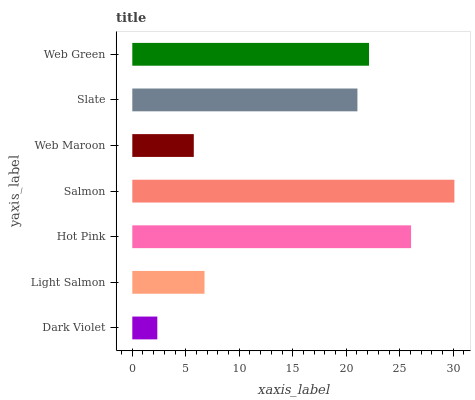Is Dark Violet the minimum?
Answer yes or no. Yes. Is Salmon the maximum?
Answer yes or no. Yes. Is Light Salmon the minimum?
Answer yes or no. No. Is Light Salmon the maximum?
Answer yes or no. No. Is Light Salmon greater than Dark Violet?
Answer yes or no. Yes. Is Dark Violet less than Light Salmon?
Answer yes or no. Yes. Is Dark Violet greater than Light Salmon?
Answer yes or no. No. Is Light Salmon less than Dark Violet?
Answer yes or no. No. Is Slate the high median?
Answer yes or no. Yes. Is Slate the low median?
Answer yes or no. Yes. Is Hot Pink the high median?
Answer yes or no. No. Is Salmon the low median?
Answer yes or no. No. 